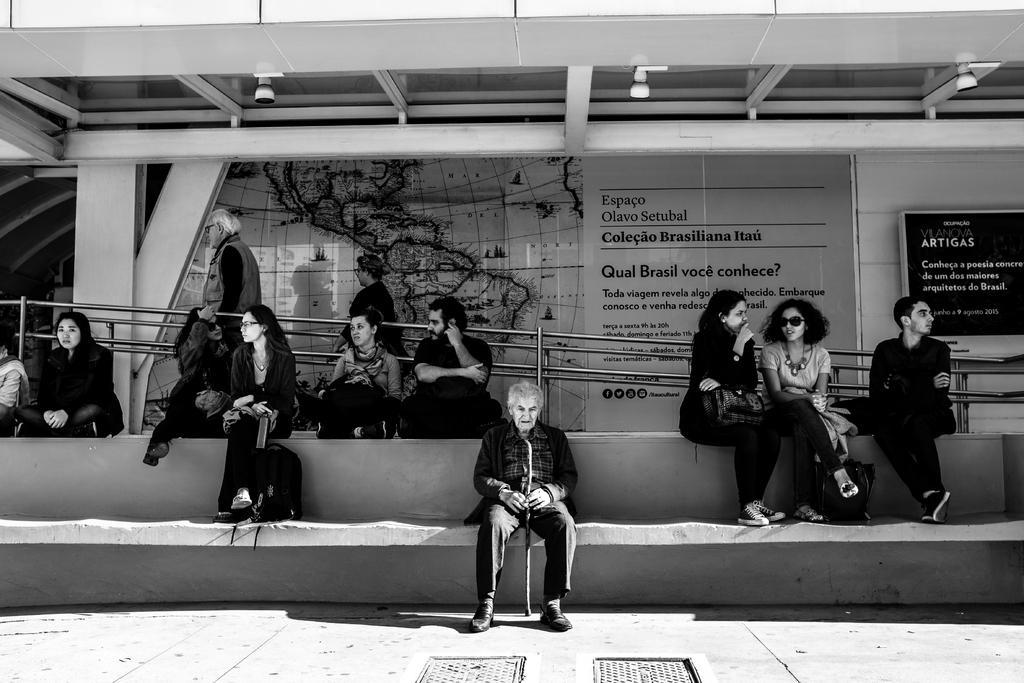Could you give a brief overview of what you see in this image? In the picture we can see some people are sitting in the bus stand on the paths near the railings and in the background we can see a wall with some paintings on it and with some information, and to the ceiling we can see some lights. 